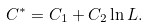<formula> <loc_0><loc_0><loc_500><loc_500>C ^ { \ast } = C _ { 1 } + C _ { 2 } \ln L .</formula> 